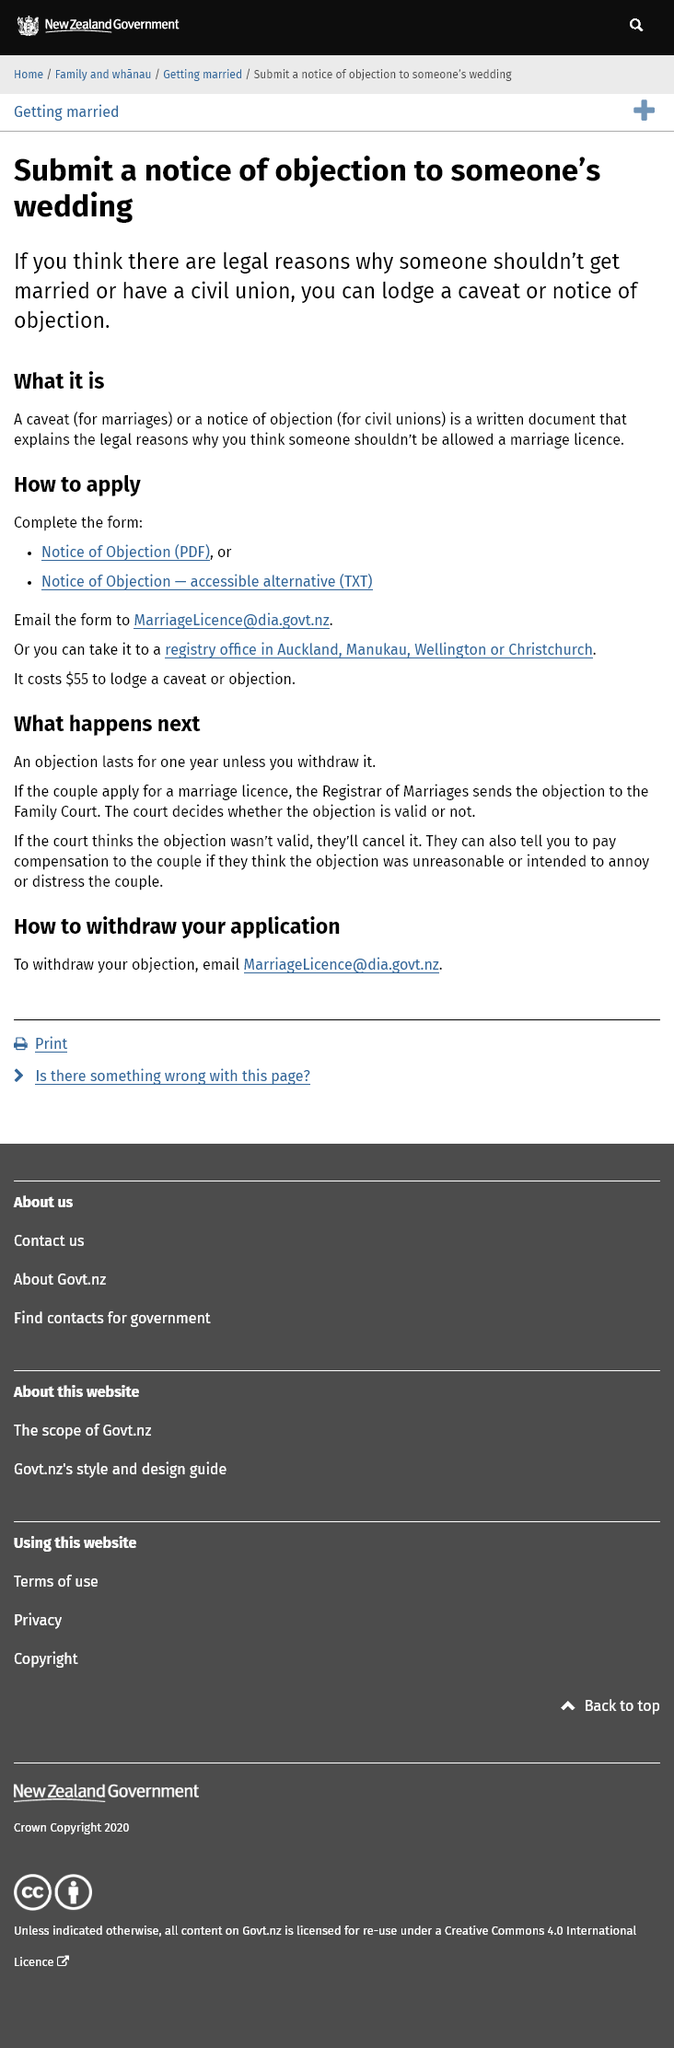Highlight a few significant elements in this photo. You can email the form to [MarriageLicence@dia.govt.nz](mailto:MarriageLicence@dia.govt.nz) in order to email the objection. A caveat is a written document that explains legal reasons why someone should not be allowed to obtain a marriage license. The cost of lodging a caveat or objection is $55. 